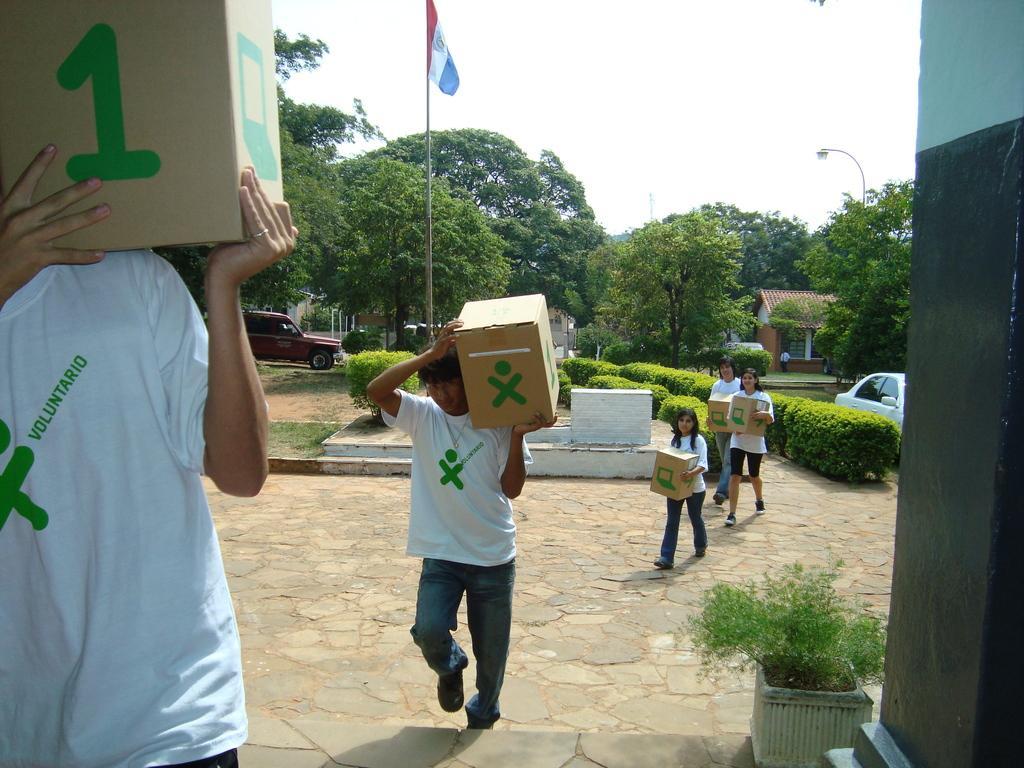Can you describe this image briefly? In this image, we can see people holding boxes and in the background, there are trees, houses, some vehicles on the road and we can see shrubs, a houseplant, a light and a flag. At the top, there is sky. 